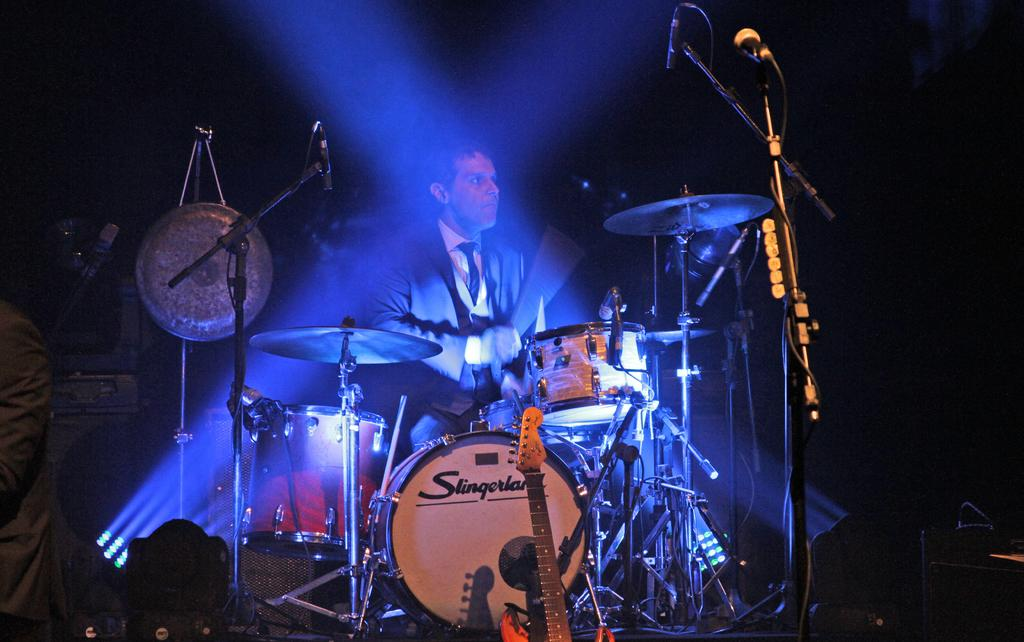What is the man in the image doing? The man is sitting and playing a drum set in the image. What other musical instrument can be seen in the image? There is a guitar in the image. Where is the guitar placed? The guitar is placed somewhere in the image. Can you describe the person standing at the left side of the image? There is a person standing at the left side of the image, but their actions or appearance are not specified in the provided facts. How many dogs are playing with the pies in the image? There are no dogs or pies present in the image. 